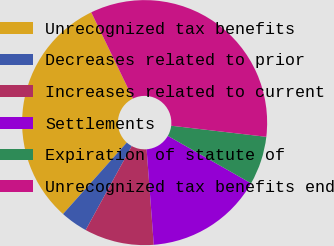Convert chart. <chart><loc_0><loc_0><loc_500><loc_500><pie_chart><fcel>Unrecognized tax benefits<fcel>Decreases related to prior<fcel>Increases related to current<fcel>Settlements<fcel>Expiration of statute of<fcel>Unrecognized tax benefits end<nl><fcel>31.23%<fcel>3.61%<fcel>9.18%<fcel>15.56%<fcel>6.4%<fcel>34.02%<nl></chart> 